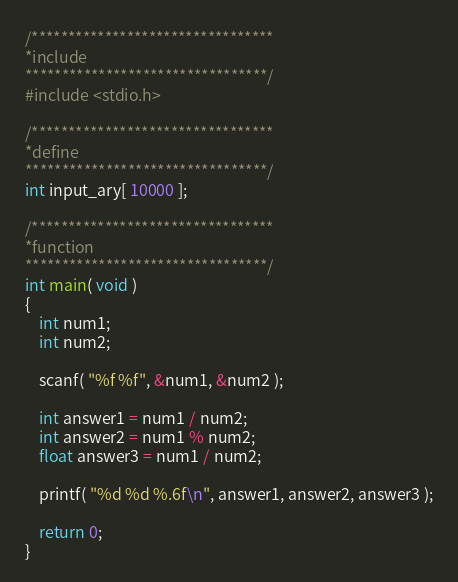<code> <loc_0><loc_0><loc_500><loc_500><_C_>/*********************************
*include
*********************************/
#include <stdio.h>

/*********************************
*define
*********************************/
int input_ary[ 10000 ];

/*********************************
*function
*********************************/
int main( void )
{
	int num1;
	int num2;

	scanf( "%f %f", &num1, &num2 );

	int answer1 = num1 / num2;
	int answer2 = num1 % num2;
	float answer3 = num1 / num2;

	printf( "%d %d %.6f\n", answer1, answer2, answer3 );

	return 0;
}</code> 